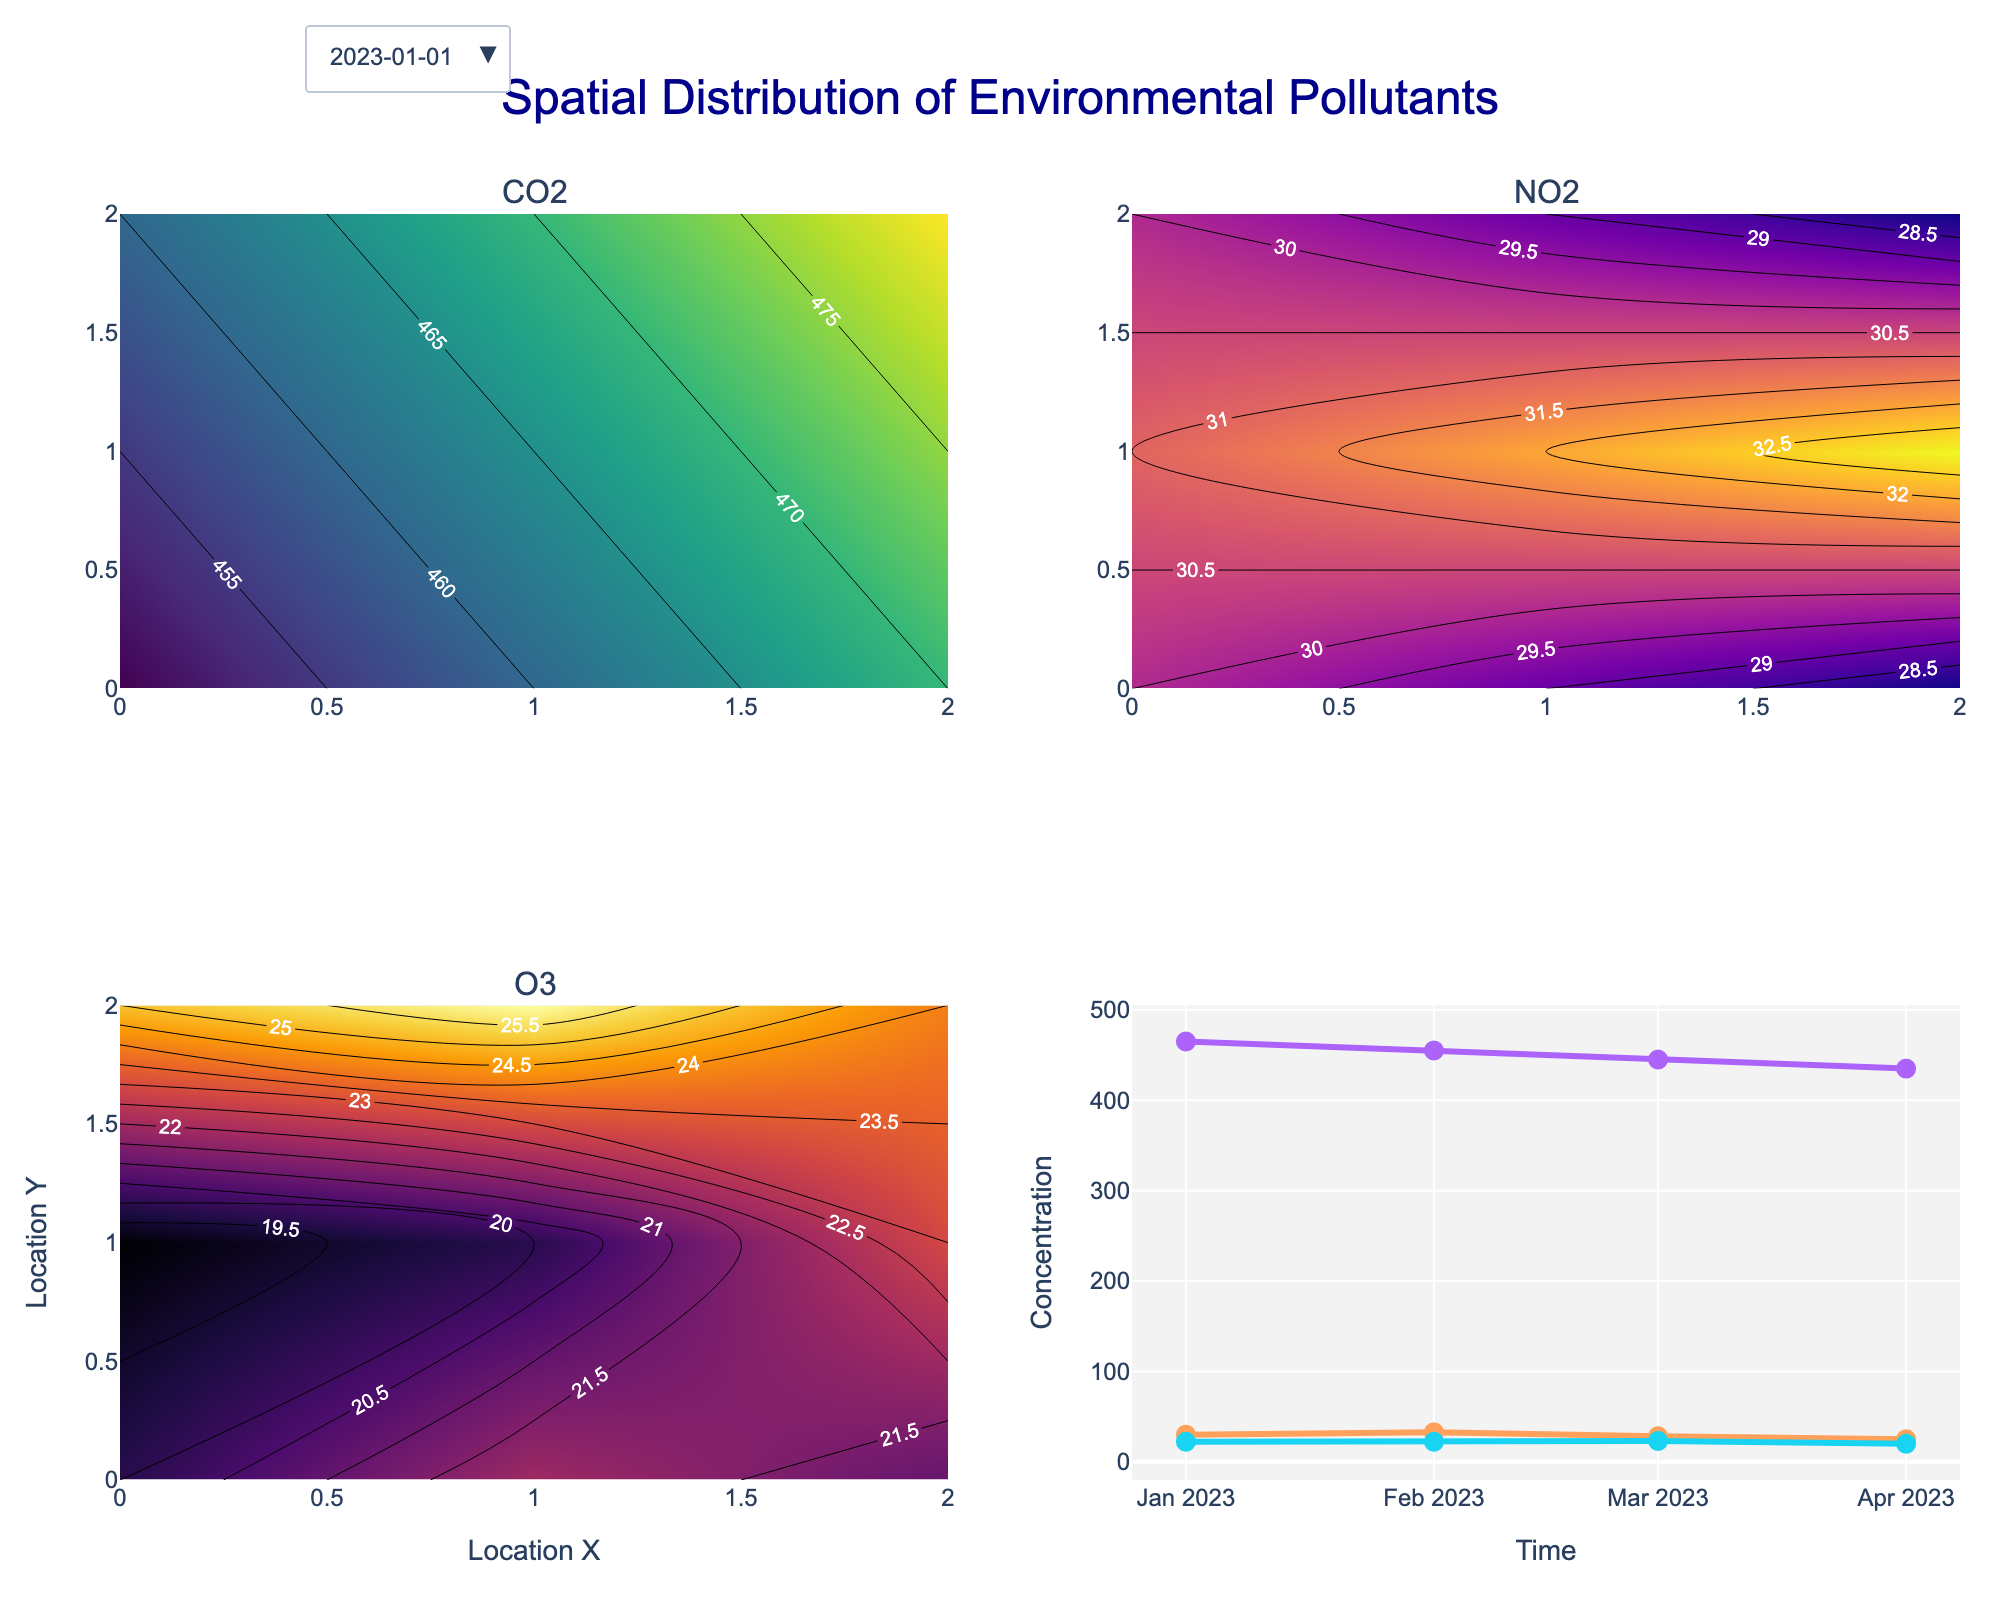What's the main title of the figure? The main title of the figure is at the top and reads "Spatial Distribution of Environmental Pollutants". This tells us that the figure is focused on the spatial distribution of various environmental pollutants.
Answer: Spatial Distribution of Environmental Pollutants Which types of pollutants are visualized in the subplots? There are three types of pollutants visualized in the subplots, which are labeled at the top of each subplot. These pollutants are CO2, NO2, and O3. All these pollutants have different color scales to distinguish them easily.
Answer: CO2, NO2, O3 How does the concentration of CO2 change over time based on the time series plot? There is a time series plot of pollutant concentrations at the bottom right subplot. This plot shows the average concentration of each pollutant over time. By looking at the trend of CO2 over different months, we can observe that CO2 concentrations gradually decrease from January to April.
Answer: Decreases Which pollutant shows the highest variety in its concentration across different locations for January 2023? Each of the contour plots on the figure shows the concentration of pollutants across different locations for January 2023. By comparing the color scales and contour lines, we observe that the NO2 plot has the most significant variations in concentration, indicating the highest variety.
Answer: NO2 Which time period can be selected using the dropdown menu? The dropdown menu in the figure allows the user to select from four different time periods: January 2023, February 2023, March 2023, and April 2023. By changing the selection, the contour plots’ data update to reflect pollutant concentrations for the chosen time period.
Answer: January 2023, February 2023, March 2023, April 2023 What is the minimum concentration of O3 in April 2023? To find the minimum concentration of O3 in April 2023, we can observe the contour plot of O3 when April 2023 is selected. The darkest area in the plot corresponds to the minimum value, which appears to be at the bottom-right corner. The contour label in that region indicates a concentration of 17.
Answer: 17 Between February and March of 2023, which pollutant shows a more significant drop in average concentration based on the time series plot? By examining the line trends in the time series plot at the bottom right, the drop in average concentration from February to March can be compared for all pollutants. O3 shows a significant drop as it decreases from around 23 to 22. In comparison, CO2 and NO2 also drop, but not as pronounced as O3.
Answer: O3 Which month has the highest average concentration of NO2? From the time series plot in the bottom-right subplot, we can compare the NO2 values over different months. January 2023 shows the highest average concentration of NO2 compared to the other months, visible as the highest point on the NO2 trend line.
Answer: January 2023 What patterns can be observed about the spatial distribution of CO2 across the locations in the given time frame? By surveying the contour plots for each month, we observe that CO2 concentrations generally form a gradient, where concentrations tend to be higher in the top-right corner and lower towards the bottom-left. This consistent pattern suggests a possible source of CO2 in the top-right area or environmental factors influencing dispersion.
Answer: Higher in the top-right, lower in the bottom-left 